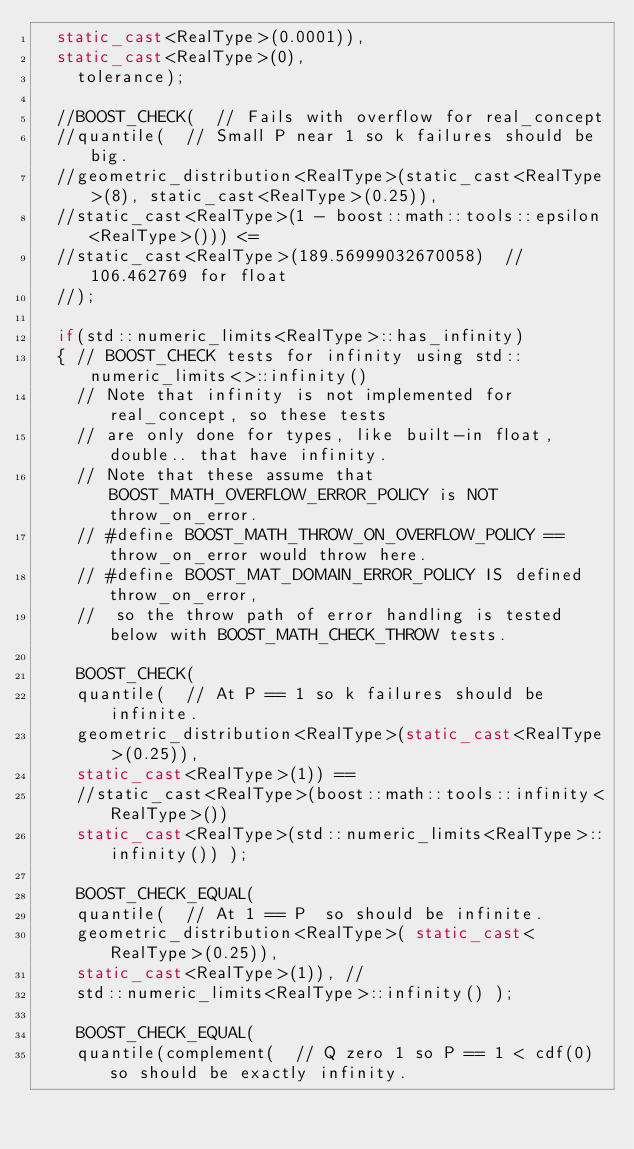Convert code to text. <code><loc_0><loc_0><loc_500><loc_500><_C++_>  static_cast<RealType>(0.0001)),
  static_cast<RealType>(0),
    tolerance);

  //BOOST_CHECK(  // Fails with overflow for real_concept
  //quantile(  // Small P near 1 so k failures should be big.
  //geometric_distribution<RealType>(static_cast<RealType>(8), static_cast<RealType>(0.25)),
  //static_cast<RealType>(1 - boost::math::tools::epsilon<RealType>())) <=
  //static_cast<RealType>(189.56999032670058)  // 106.462769 for float
  //);

  if(std::numeric_limits<RealType>::has_infinity)
  { // BOOST_CHECK tests for infinity using std::numeric_limits<>::infinity()
    // Note that infinity is not implemented for real_concept, so these tests
    // are only done for types, like built-in float, double.. that have infinity.
    // Note that these assume that  BOOST_MATH_OVERFLOW_ERROR_POLICY is NOT throw_on_error.
    // #define BOOST_MATH_THROW_ON_OVERFLOW_POLICY ==  throw_on_error would throw here.
    // #define BOOST_MAT_DOMAIN_ERROR_POLICY IS defined throw_on_error,
    //  so the throw path of error handling is tested below with BOOST_MATH_CHECK_THROW tests.

    BOOST_CHECK(
    quantile(  // At P == 1 so k failures should be infinite.
    geometric_distribution<RealType>(static_cast<RealType>(0.25)),
    static_cast<RealType>(1)) ==
    //static_cast<RealType>(boost::math::tools::infinity<RealType>())
    static_cast<RealType>(std::numeric_limits<RealType>::infinity()) );

    BOOST_CHECK_EQUAL(
    quantile(  // At 1 == P  so should be infinite.
    geometric_distribution<RealType>( static_cast<RealType>(0.25)),
    static_cast<RealType>(1)), //
    std::numeric_limits<RealType>::infinity() );

    BOOST_CHECK_EQUAL(
    quantile(complement(  // Q zero 1 so P == 1 < cdf(0) so should be exactly infinity.</code> 